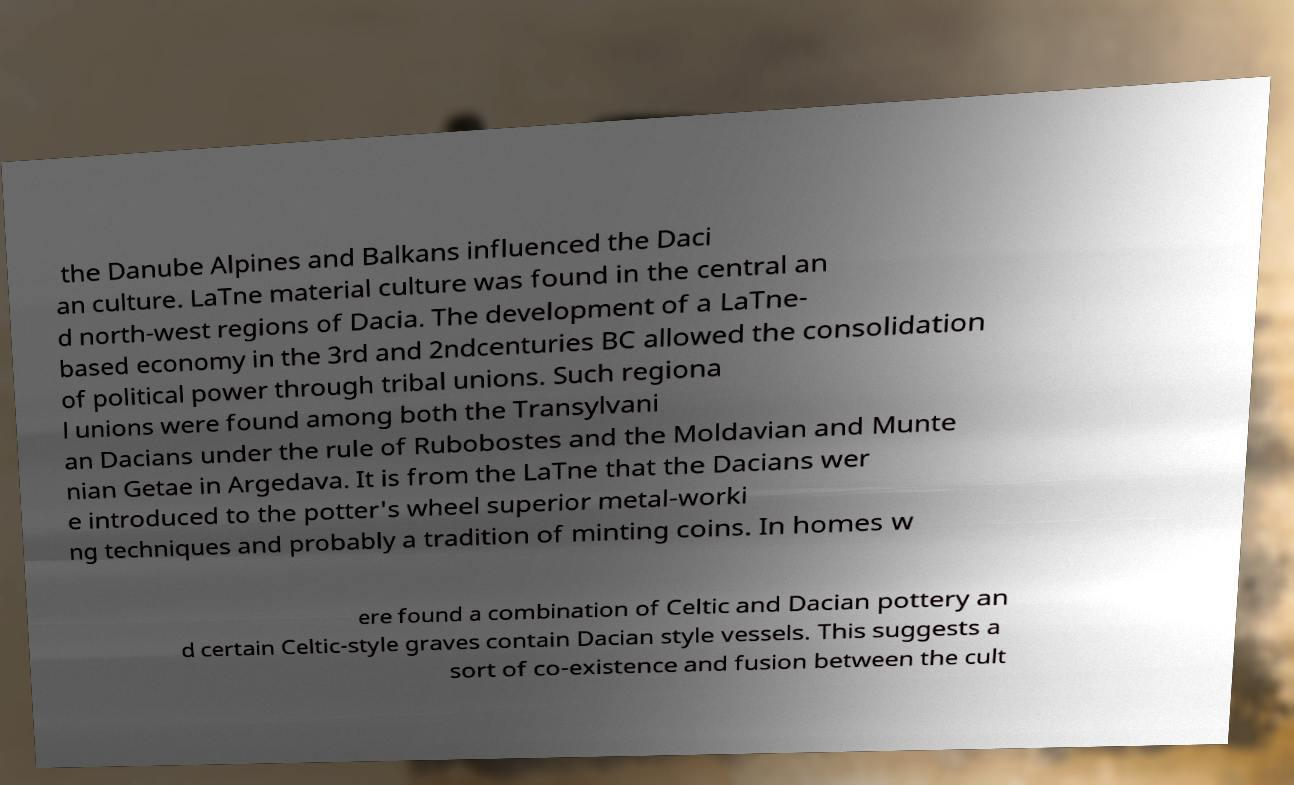Please read and relay the text visible in this image. What does it say? the Danube Alpines and Balkans influenced the Daci an culture. LaTne material culture was found in the central an d north-west regions of Dacia. The development of a LaTne- based economy in the 3rd and 2ndcenturies BC allowed the consolidation of political power through tribal unions. Such regiona l unions were found among both the Transylvani an Dacians under the rule of Rubobostes and the Moldavian and Munte nian Getae in Argedava. It is from the LaTne that the Dacians wer e introduced to the potter's wheel superior metal-worki ng techniques and probably a tradition of minting coins. In homes w ere found a combination of Celtic and Dacian pottery an d certain Celtic-style graves contain Dacian style vessels. This suggests a sort of co-existence and fusion between the cult 